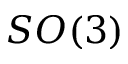<formula> <loc_0><loc_0><loc_500><loc_500>S O ( 3 )</formula> 